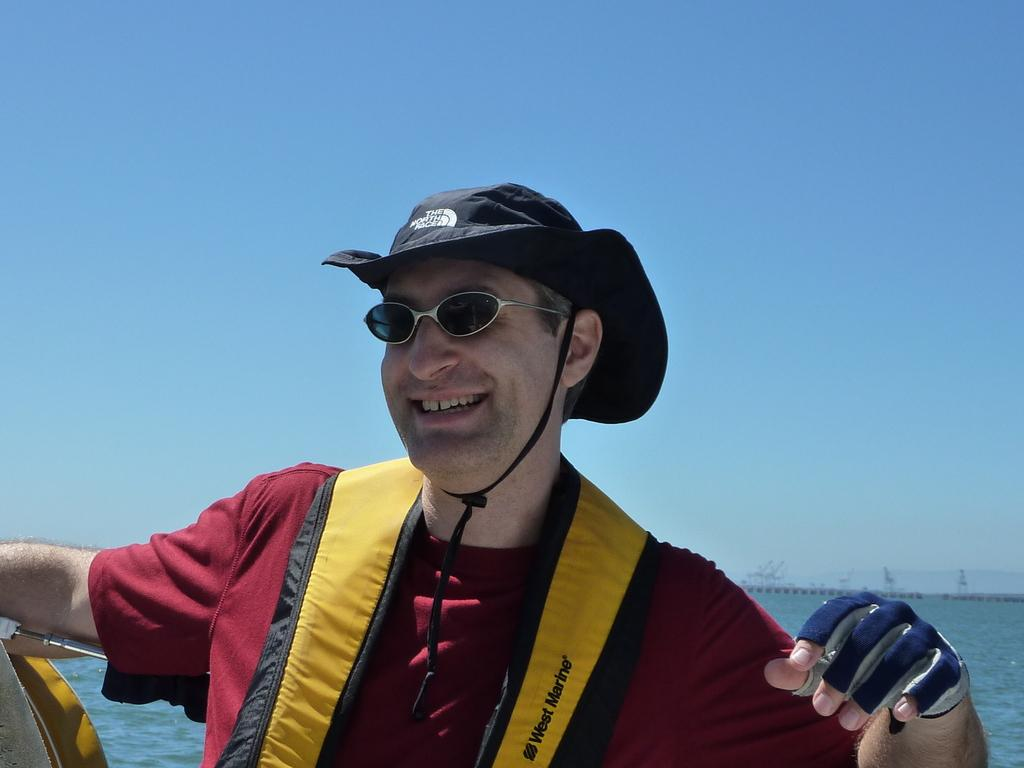Who is the main subject in the foreground of the image? There is a man in the foreground of the image. What is the man wearing on his upper body? The man is wearing a jacket. What is the man wearing on his head? The man is wearing a hat. What is the man wearing on his hands? The man is wearing gloves. What can be seen in the left bottom corner of the image? There is an object in the left bottom corner of the image. What is visible in the background of the image? Water and the sky are visible in the background of the image. What type of bag is the father carrying in the image? There is no father or bag present in the image. How does the man wash his hands in the image? The man is not washing his hands in the image; he is wearing gloves. 